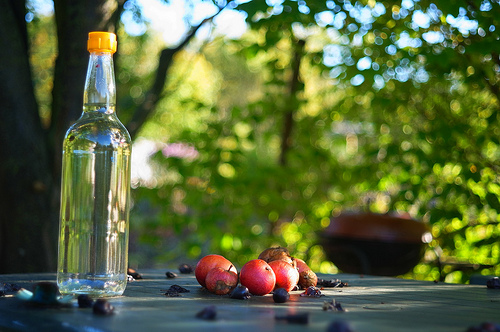What's the setting in this picture? The image shows an outdoor setting, likely a garden or backyard, with dappled sunlight shining through the leaves, highlighting a clear bottle and a cluster of ripe apples resting on a wooden surface. 